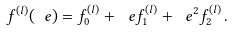Convert formula to latex. <formula><loc_0><loc_0><loc_500><loc_500>f ^ { ( l ) } ( \ e ) = f _ { 0 } ^ { ( l ) } + \ e f _ { 1 } ^ { ( l ) } + \ e ^ { 2 } f _ { 2 } ^ { ( l ) } \, .</formula> 